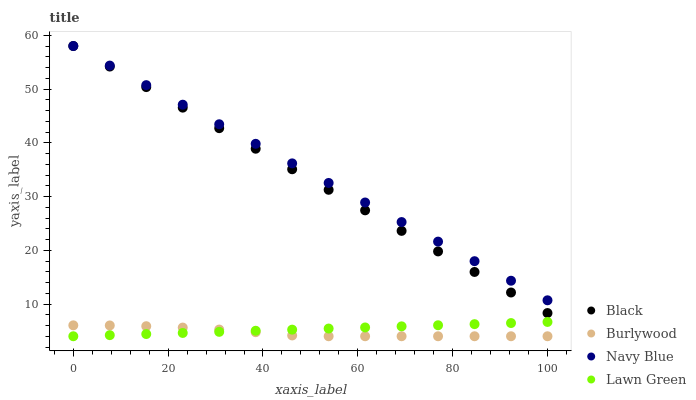Does Burlywood have the minimum area under the curve?
Answer yes or no. Yes. Does Navy Blue have the maximum area under the curve?
Answer yes or no. Yes. Does Black have the minimum area under the curve?
Answer yes or no. No. Does Black have the maximum area under the curve?
Answer yes or no. No. Is Lawn Green the smoothest?
Answer yes or no. Yes. Is Burlywood the roughest?
Answer yes or no. Yes. Is Navy Blue the smoothest?
Answer yes or no. No. Is Navy Blue the roughest?
Answer yes or no. No. Does Burlywood have the lowest value?
Answer yes or no. Yes. Does Black have the lowest value?
Answer yes or no. No. Does Black have the highest value?
Answer yes or no. Yes. Does Lawn Green have the highest value?
Answer yes or no. No. Is Lawn Green less than Black?
Answer yes or no. Yes. Is Black greater than Lawn Green?
Answer yes or no. Yes. Does Lawn Green intersect Burlywood?
Answer yes or no. Yes. Is Lawn Green less than Burlywood?
Answer yes or no. No. Is Lawn Green greater than Burlywood?
Answer yes or no. No. Does Lawn Green intersect Black?
Answer yes or no. No. 